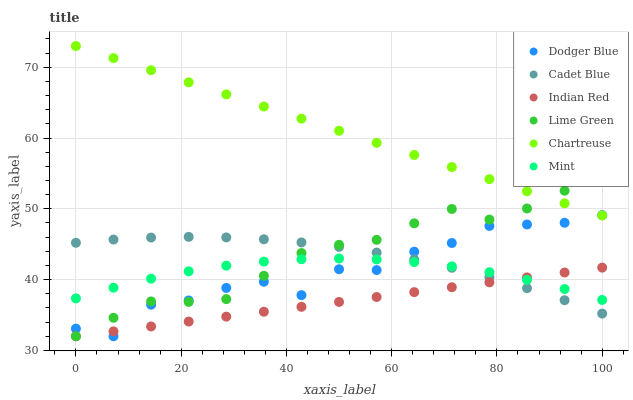Does Indian Red have the minimum area under the curve?
Answer yes or no. Yes. Does Chartreuse have the maximum area under the curve?
Answer yes or no. Yes. Does Mint have the minimum area under the curve?
Answer yes or no. No. Does Mint have the maximum area under the curve?
Answer yes or no. No. Is Indian Red the smoothest?
Answer yes or no. Yes. Is Dodger Blue the roughest?
Answer yes or no. Yes. Is Mint the smoothest?
Answer yes or no. No. Is Mint the roughest?
Answer yes or no. No. Does Dodger Blue have the lowest value?
Answer yes or no. Yes. Does Mint have the lowest value?
Answer yes or no. No. Does Chartreuse have the highest value?
Answer yes or no. Yes. Does Mint have the highest value?
Answer yes or no. No. Is Indian Red less than Chartreuse?
Answer yes or no. Yes. Is Chartreuse greater than Mint?
Answer yes or no. Yes. Does Indian Red intersect Dodger Blue?
Answer yes or no. Yes. Is Indian Red less than Dodger Blue?
Answer yes or no. No. Is Indian Red greater than Dodger Blue?
Answer yes or no. No. Does Indian Red intersect Chartreuse?
Answer yes or no. No. 